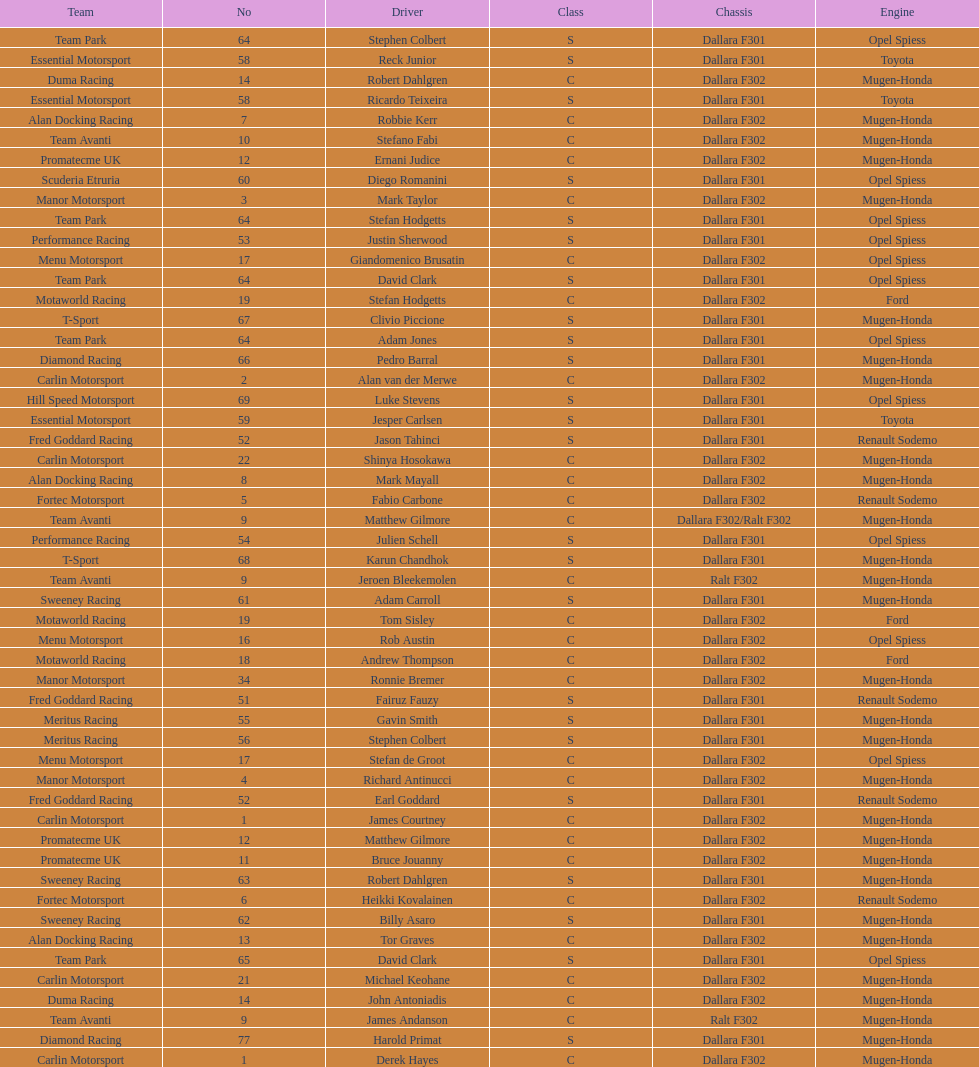What is the total number of class c (championship) teams? 21. 